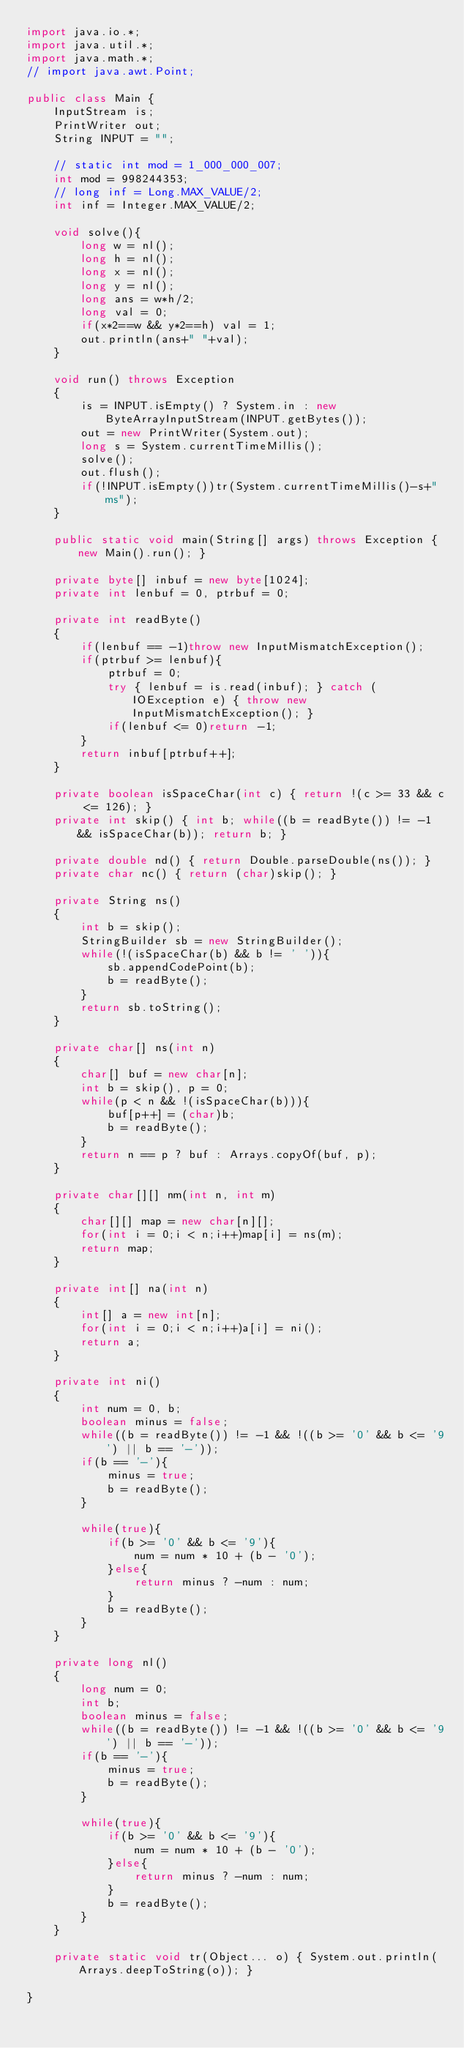<code> <loc_0><loc_0><loc_500><loc_500><_Java_>import java.io.*;
import java.util.*;
import java.math.*;
// import java.awt.Point;
 
public class Main {
    InputStream is;
    PrintWriter out;
    String INPUT = "";
 
    // static int mod = 1_000_000_007;
    int mod = 998244353;
    // long inf = Long.MAX_VALUE/2;
    int inf = Integer.MAX_VALUE/2;

    void solve(){
        long w = nl();
        long h = nl();
        long x = nl();
        long y = nl();
        long ans = w*h/2;
        long val = 0;
        if(x*2==w && y*2==h) val = 1;
        out.println(ans+" "+val);
    }

    void run() throws Exception
    {
        is = INPUT.isEmpty() ? System.in : new ByteArrayInputStream(INPUT.getBytes());
        out = new PrintWriter(System.out);
        long s = System.currentTimeMillis();
        solve();
        out.flush();
        if(!INPUT.isEmpty())tr(System.currentTimeMillis()-s+"ms");
    }
    
    public static void main(String[] args) throws Exception { new Main().run(); }
    
    private byte[] inbuf = new byte[1024];
    private int lenbuf = 0, ptrbuf = 0;
    
    private int readByte()
    {
        if(lenbuf == -1)throw new InputMismatchException();
        if(ptrbuf >= lenbuf){
            ptrbuf = 0;
            try { lenbuf = is.read(inbuf); } catch (IOException e) { throw new InputMismatchException(); }
            if(lenbuf <= 0)return -1;
        }
        return inbuf[ptrbuf++];
    }
    
    private boolean isSpaceChar(int c) { return !(c >= 33 && c <= 126); }
    private int skip() { int b; while((b = readByte()) != -1 && isSpaceChar(b)); return b; }
    
    private double nd() { return Double.parseDouble(ns()); }
    private char nc() { return (char)skip(); }
    
    private String ns()
    {
        int b = skip();
        StringBuilder sb = new StringBuilder();
        while(!(isSpaceChar(b) && b != ' ')){
            sb.appendCodePoint(b);
            b = readByte();
        }
        return sb.toString();
    }
    
    private char[] ns(int n)
    {
        char[] buf = new char[n];
        int b = skip(), p = 0;
        while(p < n && !(isSpaceChar(b))){
            buf[p++] = (char)b;
            b = readByte();
        }
        return n == p ? buf : Arrays.copyOf(buf, p);
    }
    
    private char[][] nm(int n, int m)
    {
        char[][] map = new char[n][];
        for(int i = 0;i < n;i++)map[i] = ns(m);
        return map;
    }
    
    private int[] na(int n)
    {
        int[] a = new int[n];
        for(int i = 0;i < n;i++)a[i] = ni();
        return a;
    }
    
    private int ni()
    {
        int num = 0, b;
        boolean minus = false;
        while((b = readByte()) != -1 && !((b >= '0' && b <= '9') || b == '-'));
        if(b == '-'){
            minus = true;
            b = readByte();
        }
        
        while(true){
            if(b >= '0' && b <= '9'){
                num = num * 10 + (b - '0');
            }else{
                return minus ? -num : num;
            }
            b = readByte();
        }
    }
    
    private long nl()
    {
        long num = 0;
        int b;
        boolean minus = false;
        while((b = readByte()) != -1 && !((b >= '0' && b <= '9') || b == '-'));
        if(b == '-'){
            minus = true;
            b = readByte();
        }
        
        while(true){
            if(b >= '0' && b <= '9'){
                num = num * 10 + (b - '0');
            }else{
                return minus ? -num : num;
            }
            b = readByte();
        }
    }
    
    private static void tr(Object... o) { System.out.println(Arrays.deepToString(o)); }
 
}
</code> 